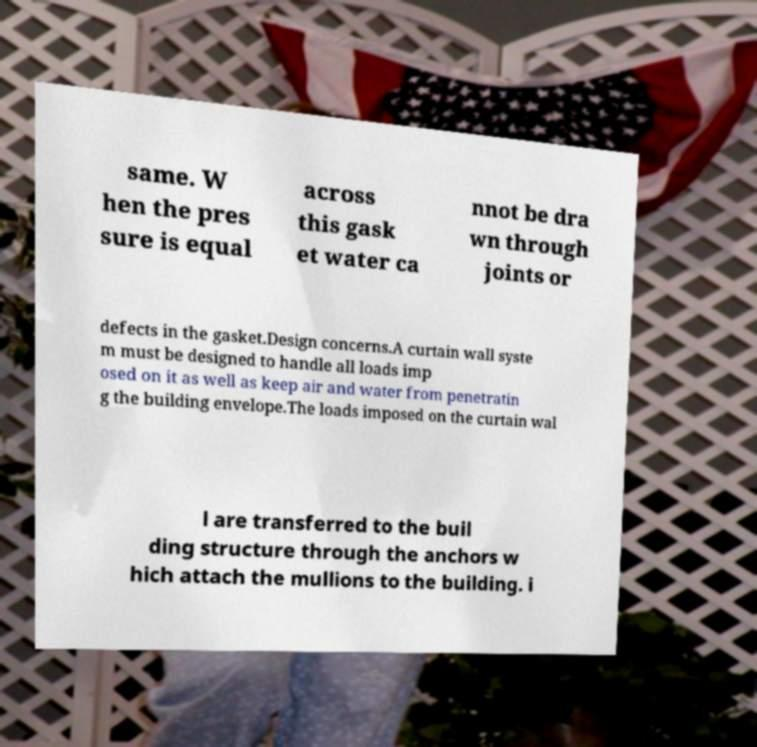Could you assist in decoding the text presented in this image and type it out clearly? same. W hen the pres sure is equal across this gask et water ca nnot be dra wn through joints or defects in the gasket.Design concerns.A curtain wall syste m must be designed to handle all loads imp osed on it as well as keep air and water from penetratin g the building envelope.The loads imposed on the curtain wal l are transferred to the buil ding structure through the anchors w hich attach the mullions to the building. i 